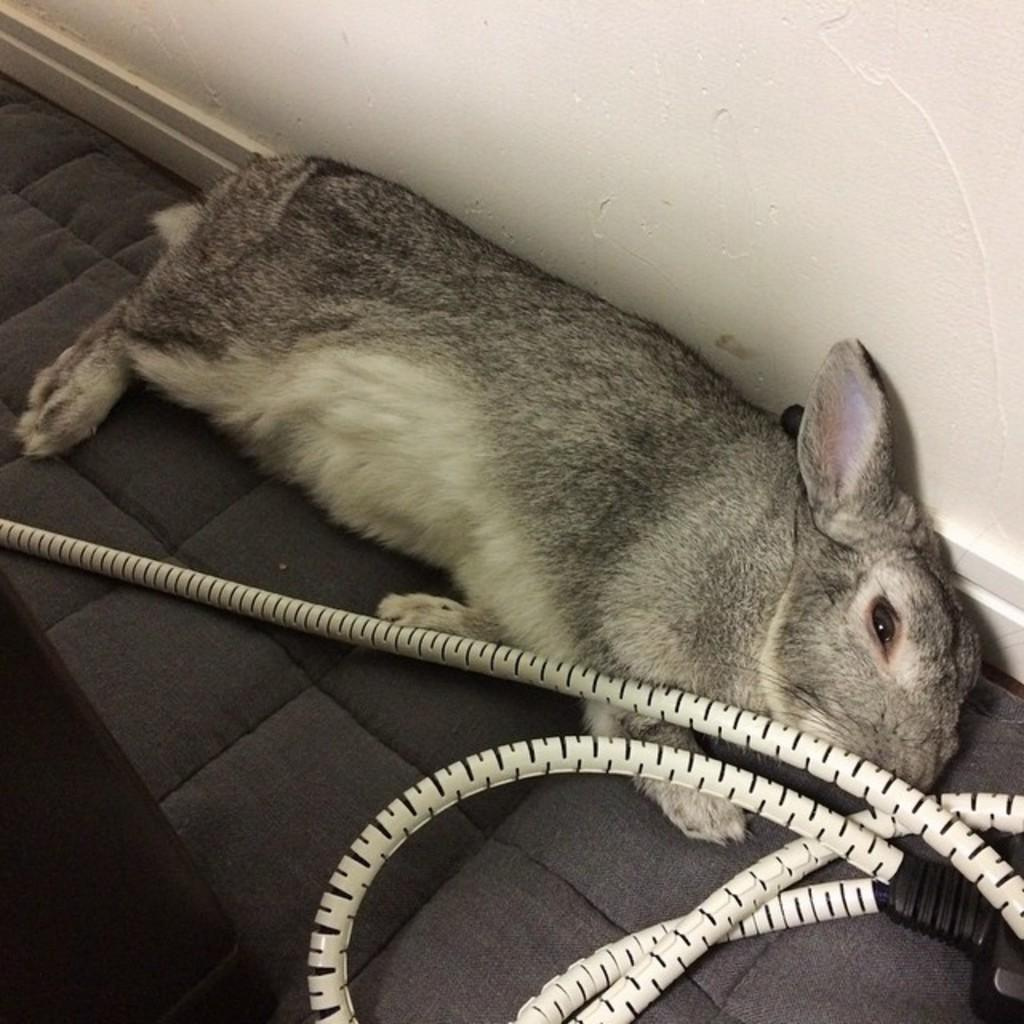What animal is lying on the floor in the image? There is a rabbit lying on the floor in the image. What else can be seen in the image besides the rabbit? There is a cable visible in the image. What color is the wall in the background of the image? There is a white wall in the background of the image. What type of receipt is the rabbit holding in the image? There is no receipt present in the image, and the rabbit is not holding anything. 